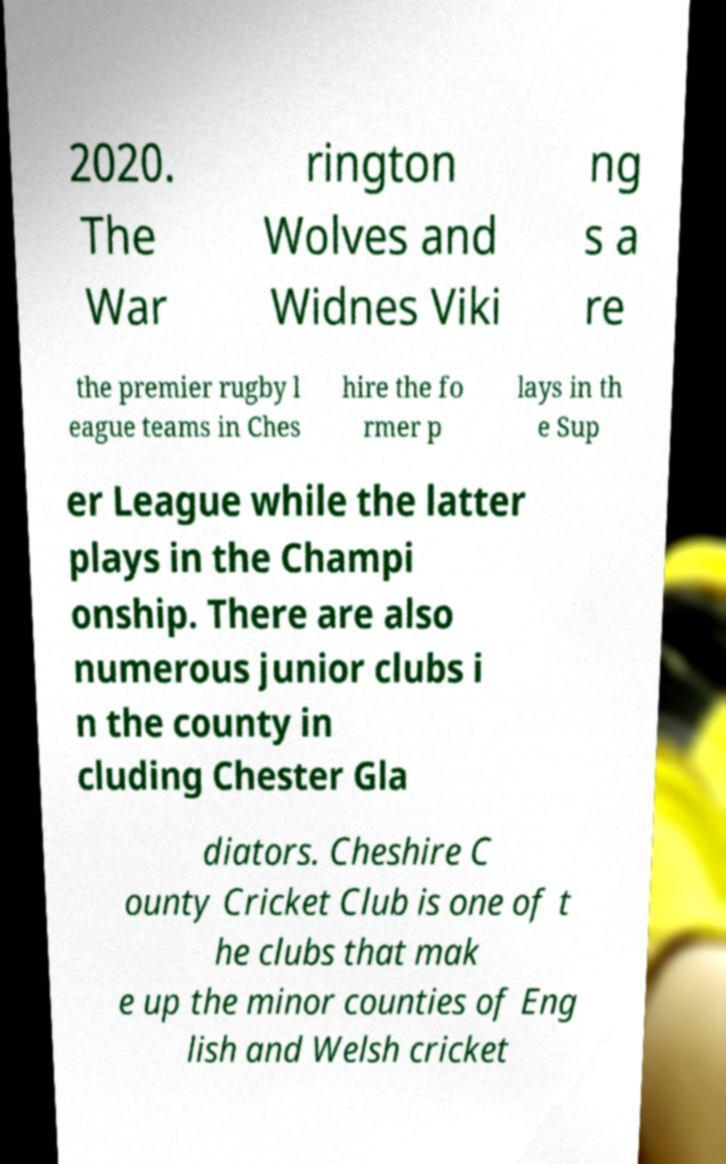Can you accurately transcribe the text from the provided image for me? 2020. The War rington Wolves and Widnes Viki ng s a re the premier rugby l eague teams in Ches hire the fo rmer p lays in th e Sup er League while the latter plays in the Champi onship. There are also numerous junior clubs i n the county in cluding Chester Gla diators. Cheshire C ounty Cricket Club is one of t he clubs that mak e up the minor counties of Eng lish and Welsh cricket 